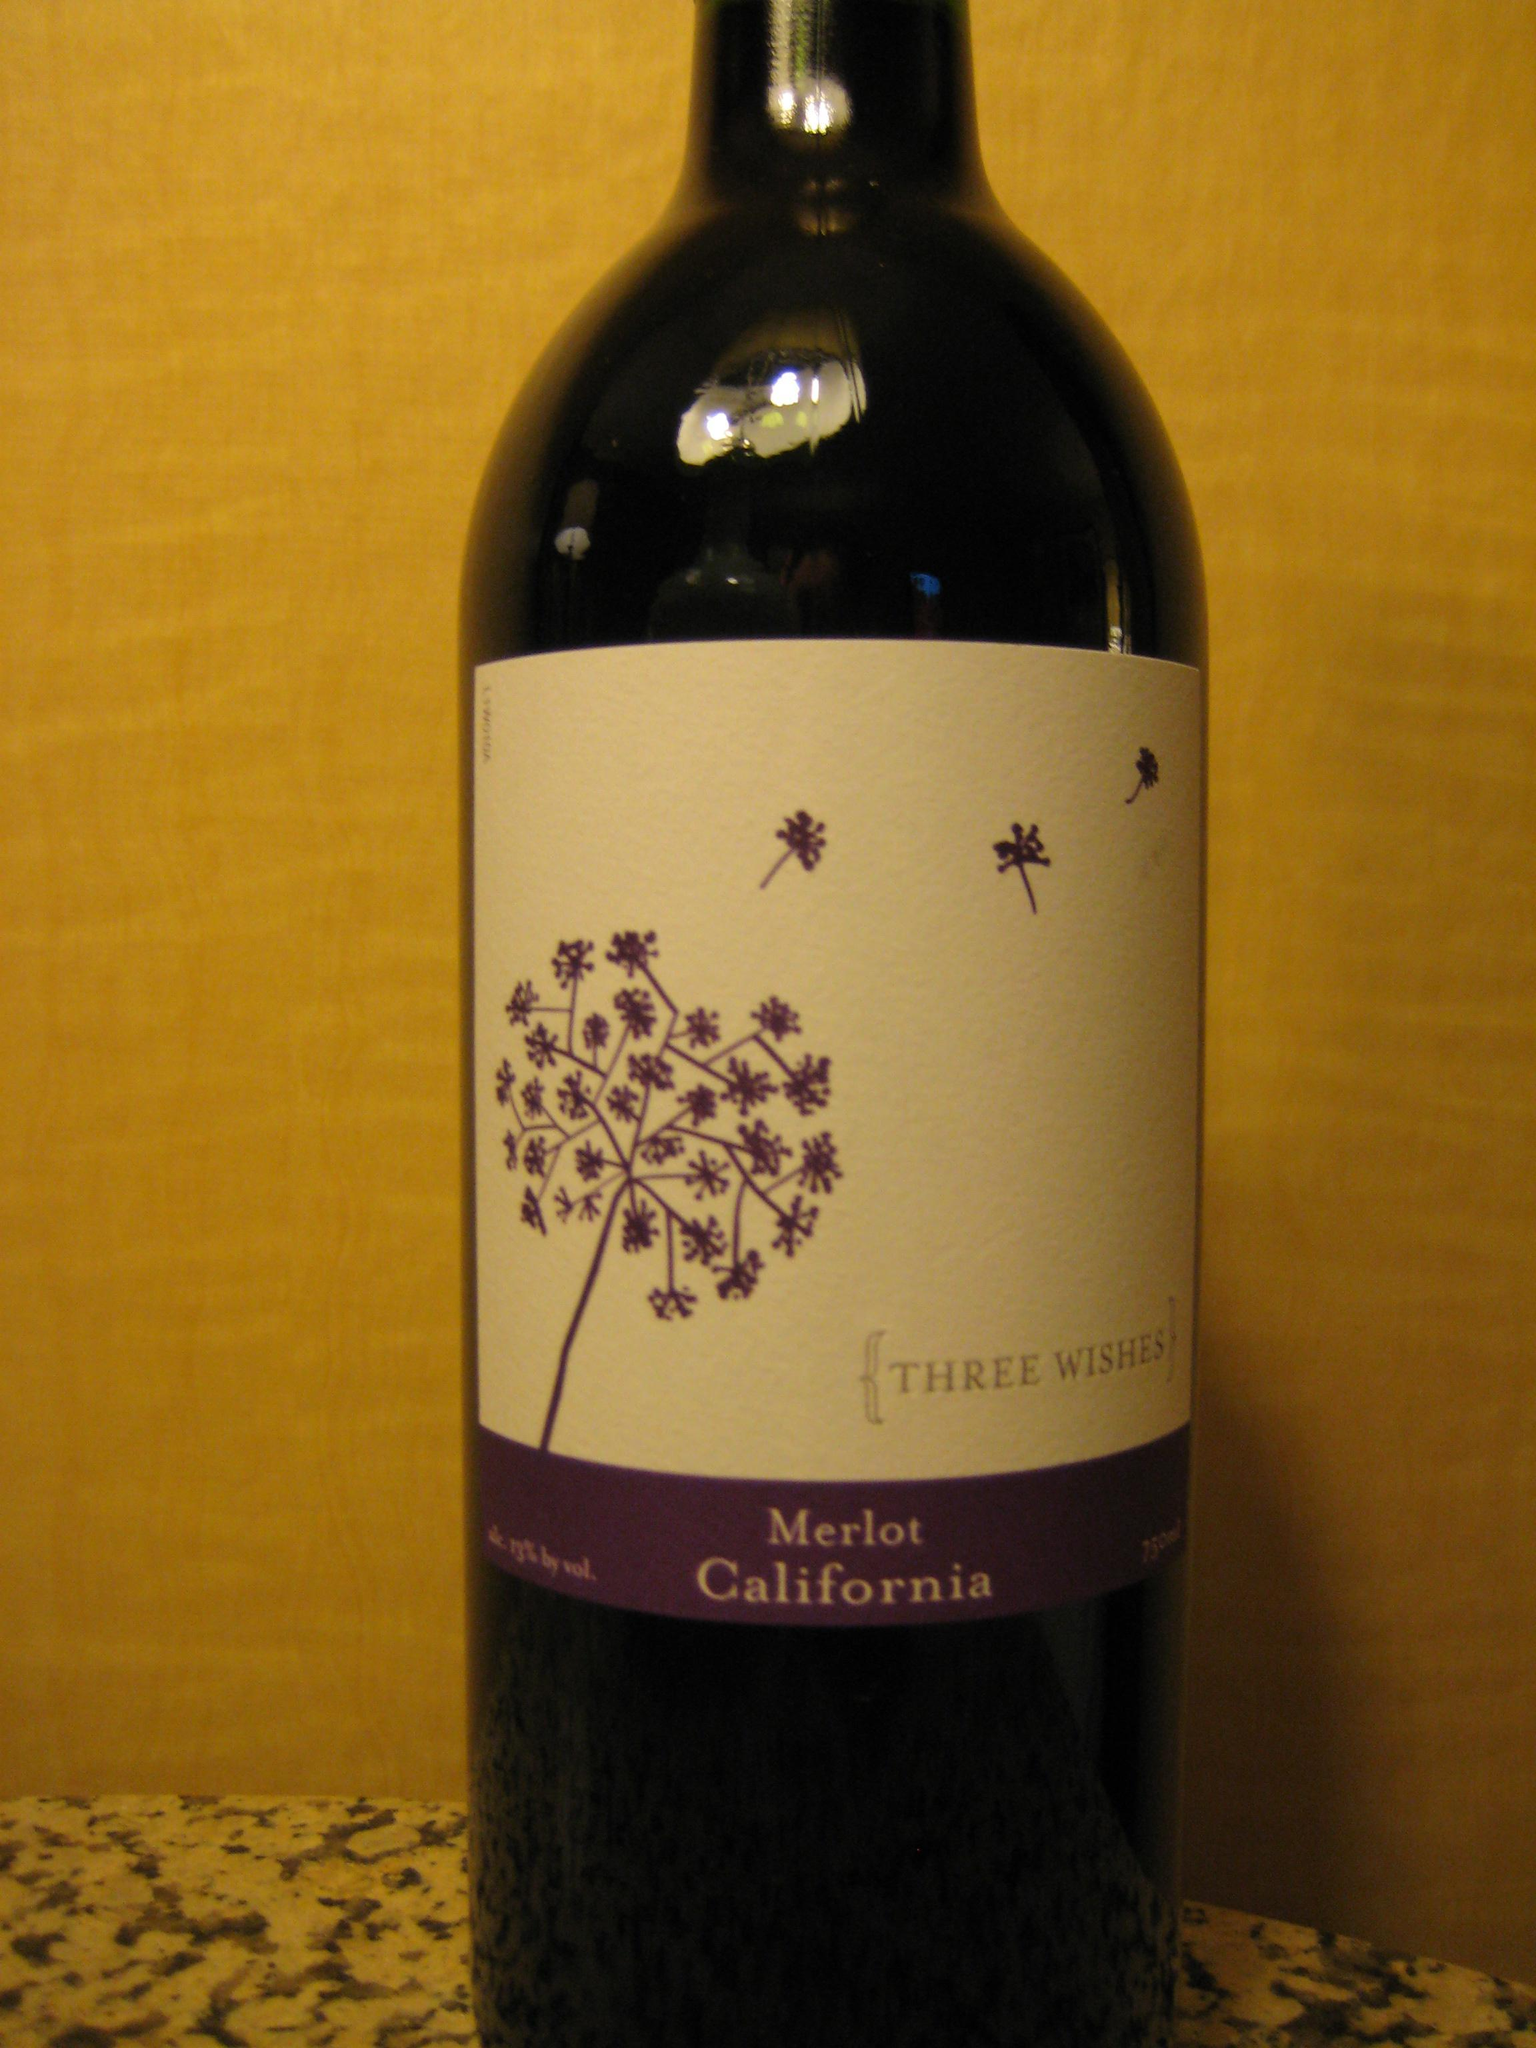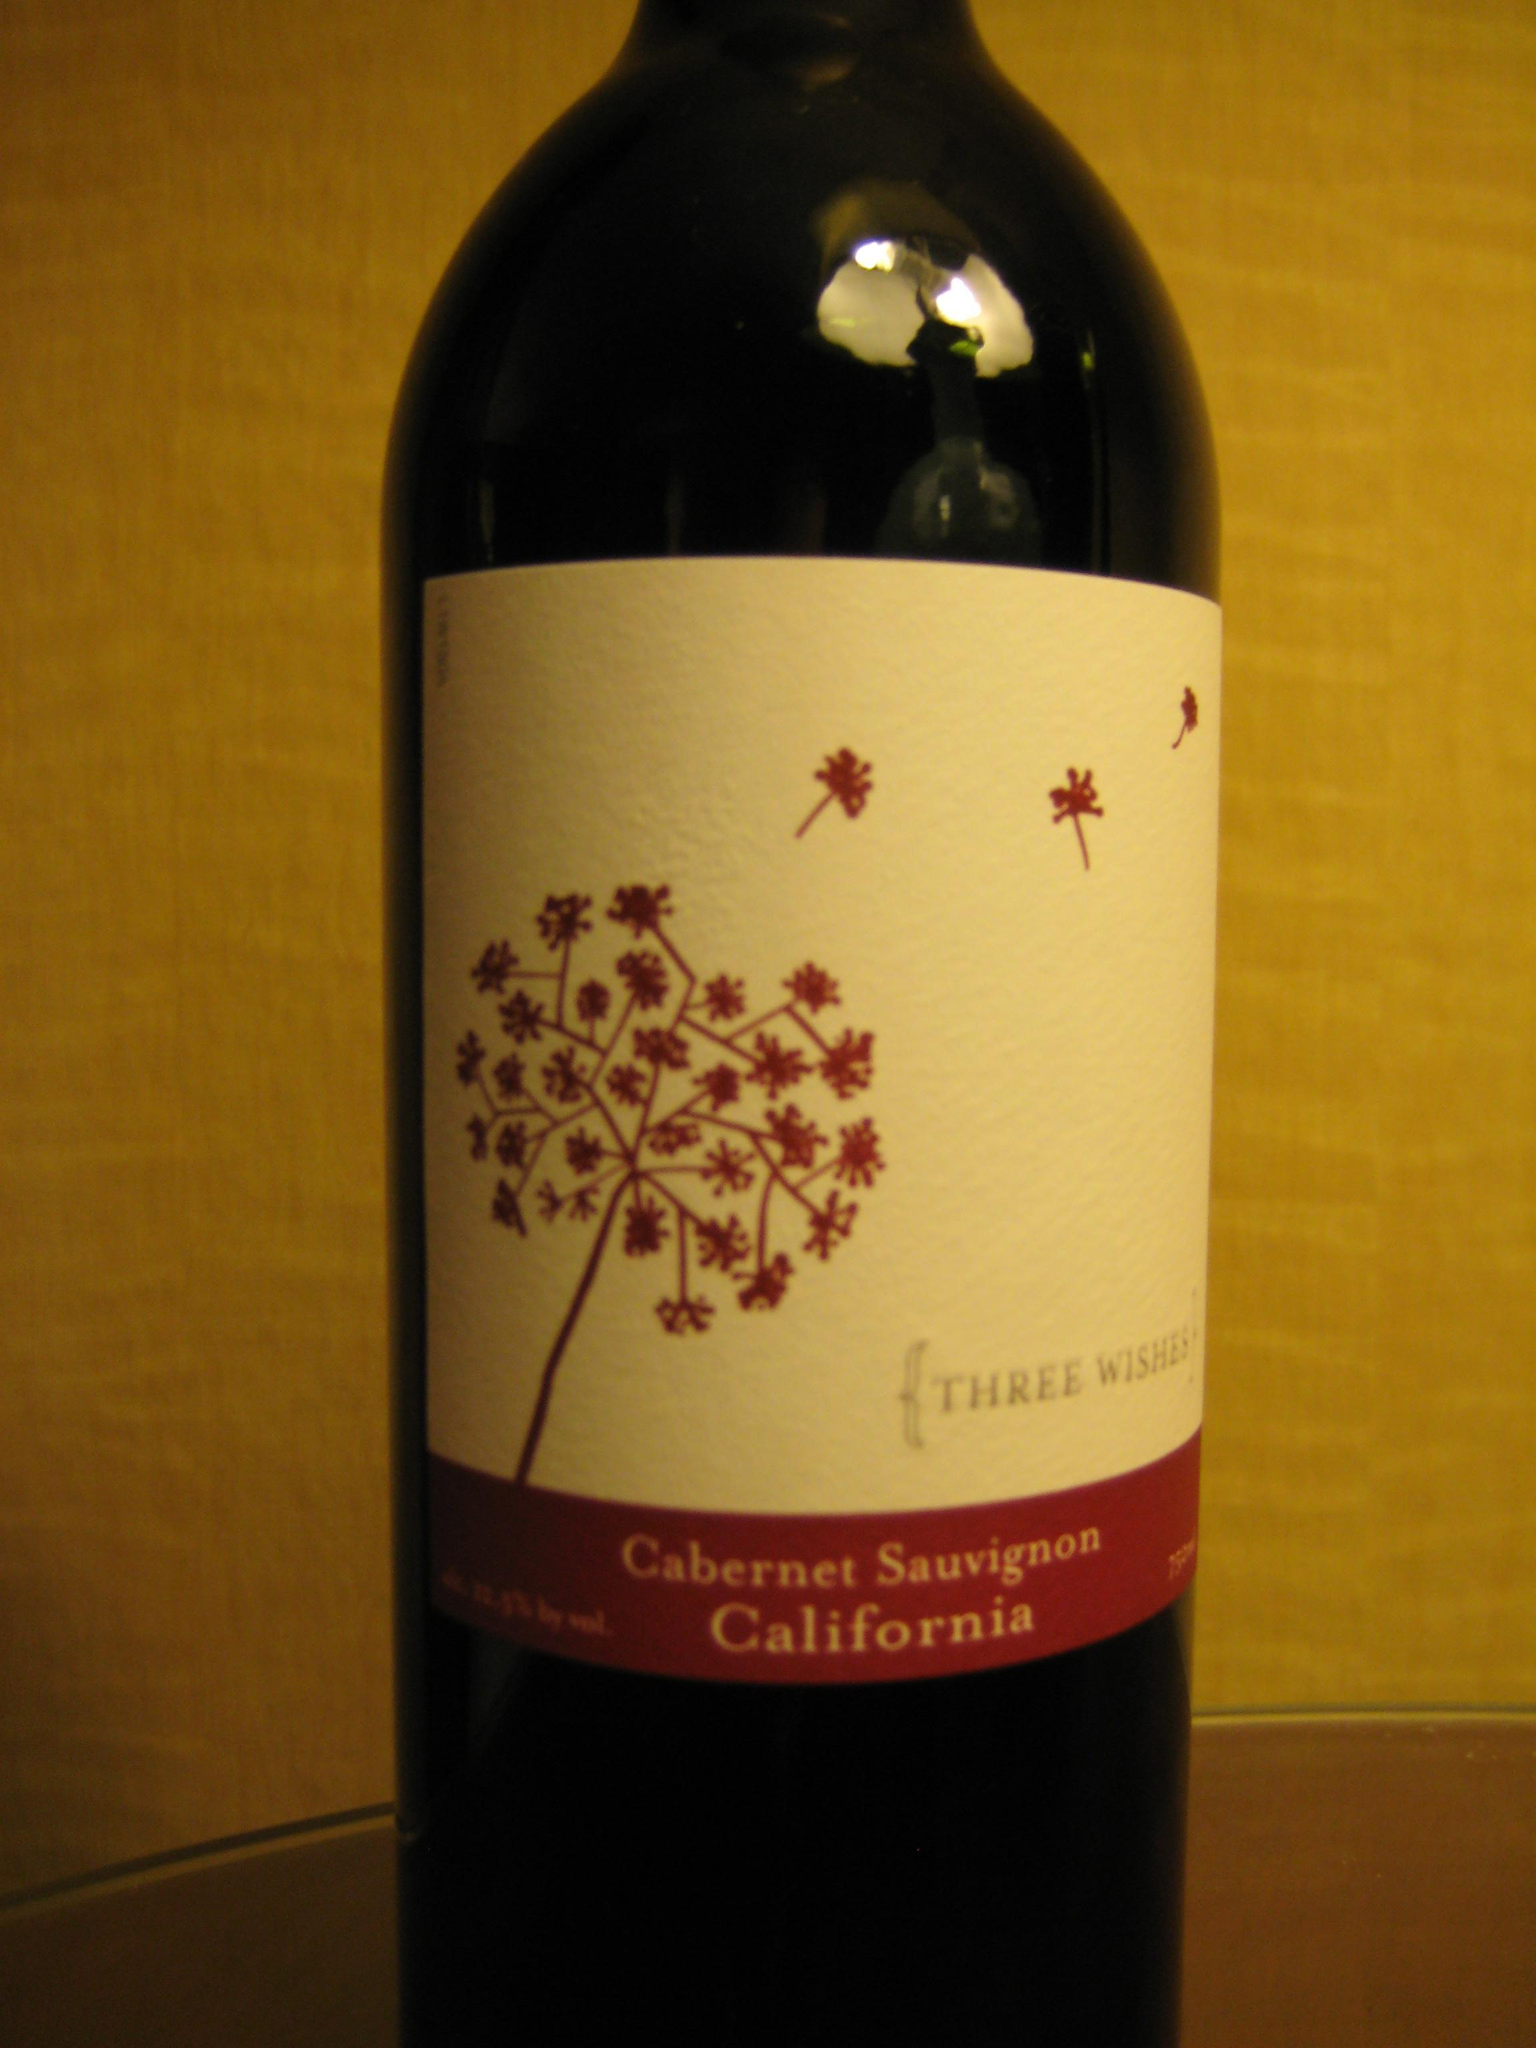The first image is the image on the left, the second image is the image on the right. Evaluate the accuracy of this statement regarding the images: "There are exactly three bottles of wine featured in one of the images.". Is it true? Answer yes or no. No. 